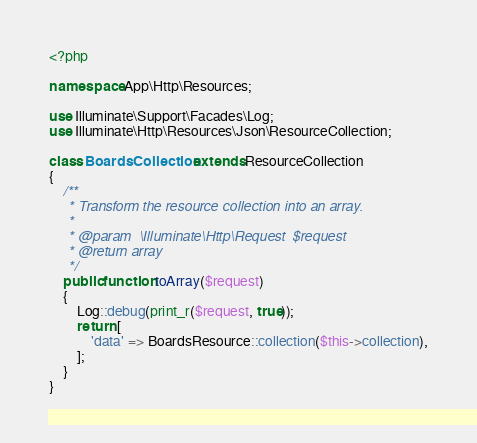<code> <loc_0><loc_0><loc_500><loc_500><_PHP_><?php

namespace App\Http\Resources;

use Illuminate\Support\Facades\Log;
use Illuminate\Http\Resources\Json\ResourceCollection;

class BoardsCollection extends ResourceCollection
{
    /**
     * Transform the resource collection into an array.
     *
     * @param  \Illuminate\Http\Request  $request
     * @return array
     */
    public function toArray($request)
    {
        Log::debug(print_r($request, true));
        return [
            'data' => BoardsResource::collection($this->collection),
        ];
    }
}
</code> 